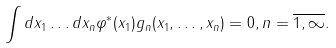Convert formula to latex. <formula><loc_0><loc_0><loc_500><loc_500>\int d x _ { 1 } \dots d x _ { n } \varphi ^ { * } ( x _ { 1 } ) g _ { n } ( x _ { 1 } , \dots , x _ { n } ) = 0 , n = \overline { 1 , \infty } .</formula> 